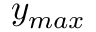<formula> <loc_0><loc_0><loc_500><loc_500>y _ { \max }</formula> 